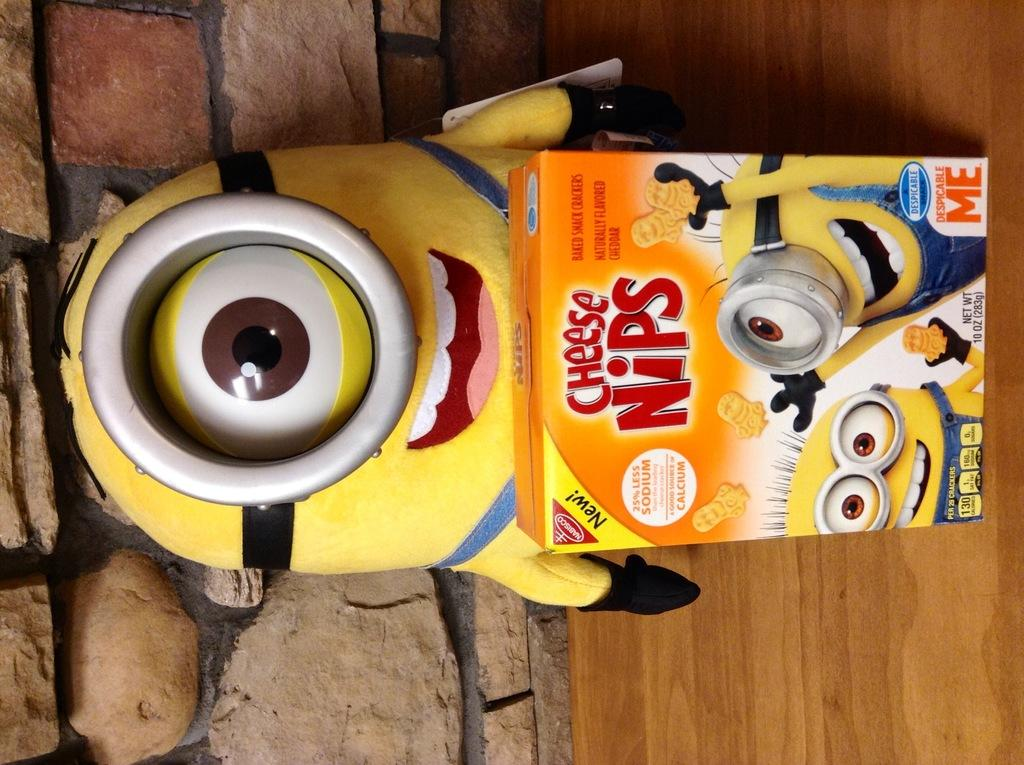What is the main subject of the image? There is a doll in the image. What other object can be seen in the image? There is a cardboard carton in the image. How many cobwebs can be seen in the image? There are no cobwebs present in the image. What shape is the doll in the image? The shape of the doll cannot be determined from the image alone, as it is a 2D representation. 